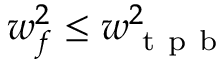<formula> <loc_0><loc_0><loc_500><loc_500>w _ { f } ^ { 2 } \leq w _ { t p b } ^ { 2 }</formula> 